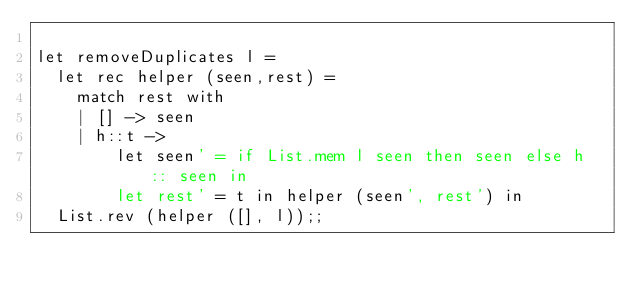<code> <loc_0><loc_0><loc_500><loc_500><_OCaml_>
let removeDuplicates l =
  let rec helper (seen,rest) =
    match rest with
    | [] -> seen
    | h::t ->
        let seen' = if List.mem l seen then seen else h :: seen in
        let rest' = t in helper (seen', rest') in
  List.rev (helper ([], l));;
</code> 